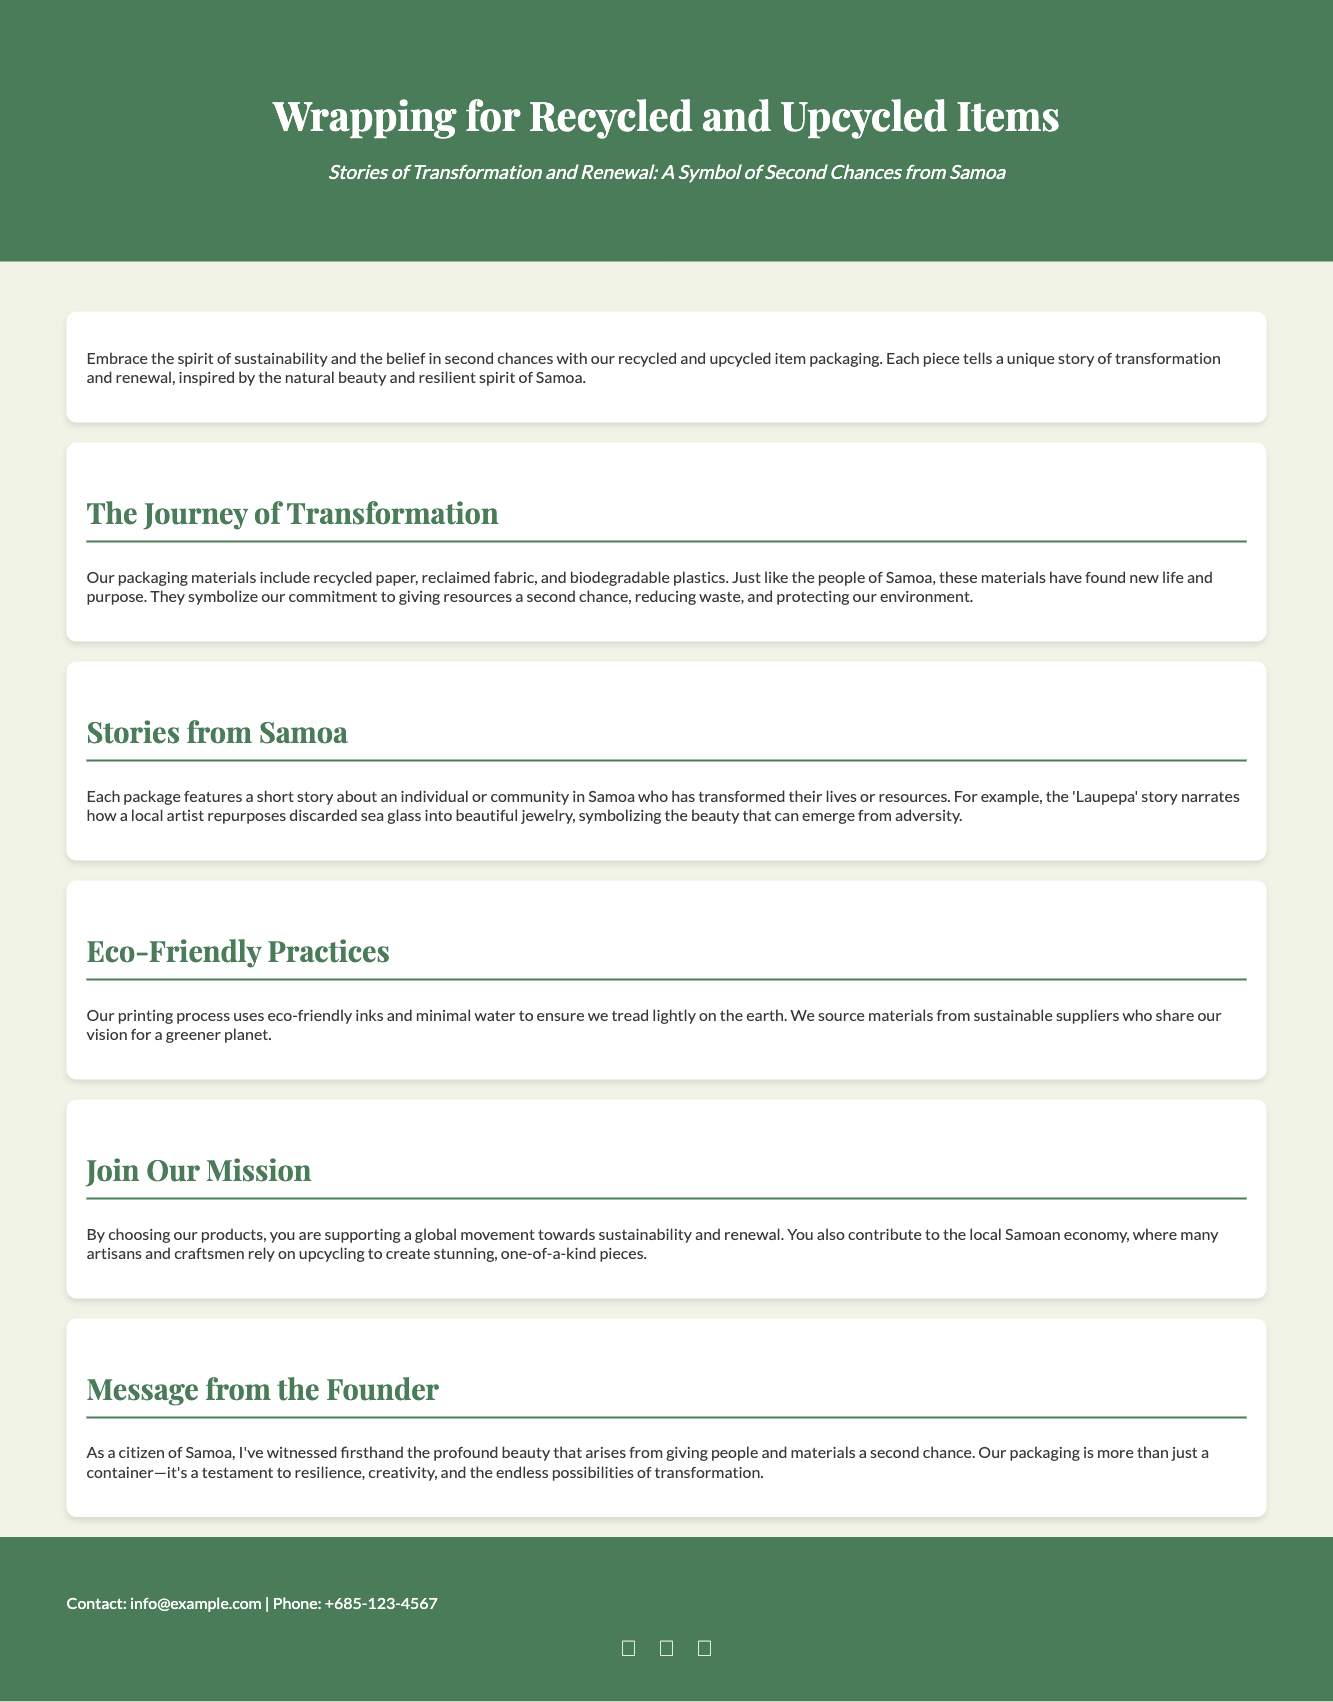What does the packaging symbolize? The packaging symbolizes the commitment to giving resources a second chance, reducing waste, and protecting the environment.
Answer: Commitment to second chances What materials are used in the packaging? The packaging uses recycled paper, reclaimed fabric, and biodegradable plastics.
Answer: Recycled paper, reclaimed fabric, biodegradable plastics What story does the 'Laupepa' narrative tell? The 'Laupepa' story narrates how a local artist repurposes discarded sea glass into beautiful jewelry.
Answer: Repurposing sea glass What type of inks does the printing process use? The printing process uses eco-friendly inks.
Answer: Eco-friendly inks Who benefits from purchasing these products? By choosing the products, customers support a global movement towards sustainability and renewal, contributing to the local Samoan economy.
Answer: Local Samoan economy What is the main theme of the document? The main theme is sustainability and the belief in second chances through recycled and upcycled item packaging.
Answer: Sustainability and second chances What is the founder's perspective on the packaging? The founder views the packaging as a testament to resilience, creativity, and the endless possibilities of transformation.
Answer: Testament to resilience and creativity What is the subtitle of the document? The subtitle emphasizes stories of transformation and renewal from Samoa.
Answer: Stories of Transformation and Renewal 